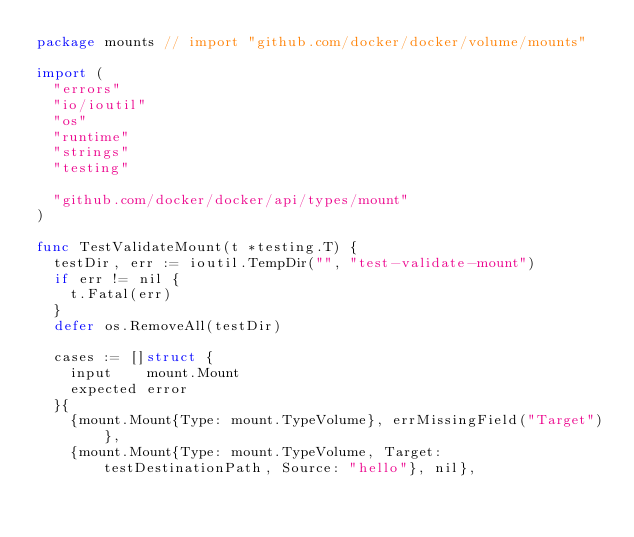Convert code to text. <code><loc_0><loc_0><loc_500><loc_500><_Go_>package mounts // import "github.com/docker/docker/volume/mounts"

import (
	"errors"
	"io/ioutil"
	"os"
	"runtime"
	"strings"
	"testing"

	"github.com/docker/docker/api/types/mount"
)

func TestValidateMount(t *testing.T) {
	testDir, err := ioutil.TempDir("", "test-validate-mount")
	if err != nil {
		t.Fatal(err)
	}
	defer os.RemoveAll(testDir)

	cases := []struct {
		input    mount.Mount
		expected error
	}{
		{mount.Mount{Type: mount.TypeVolume}, errMissingField("Target")},
		{mount.Mount{Type: mount.TypeVolume, Target: testDestinationPath, Source: "hello"}, nil},</code> 